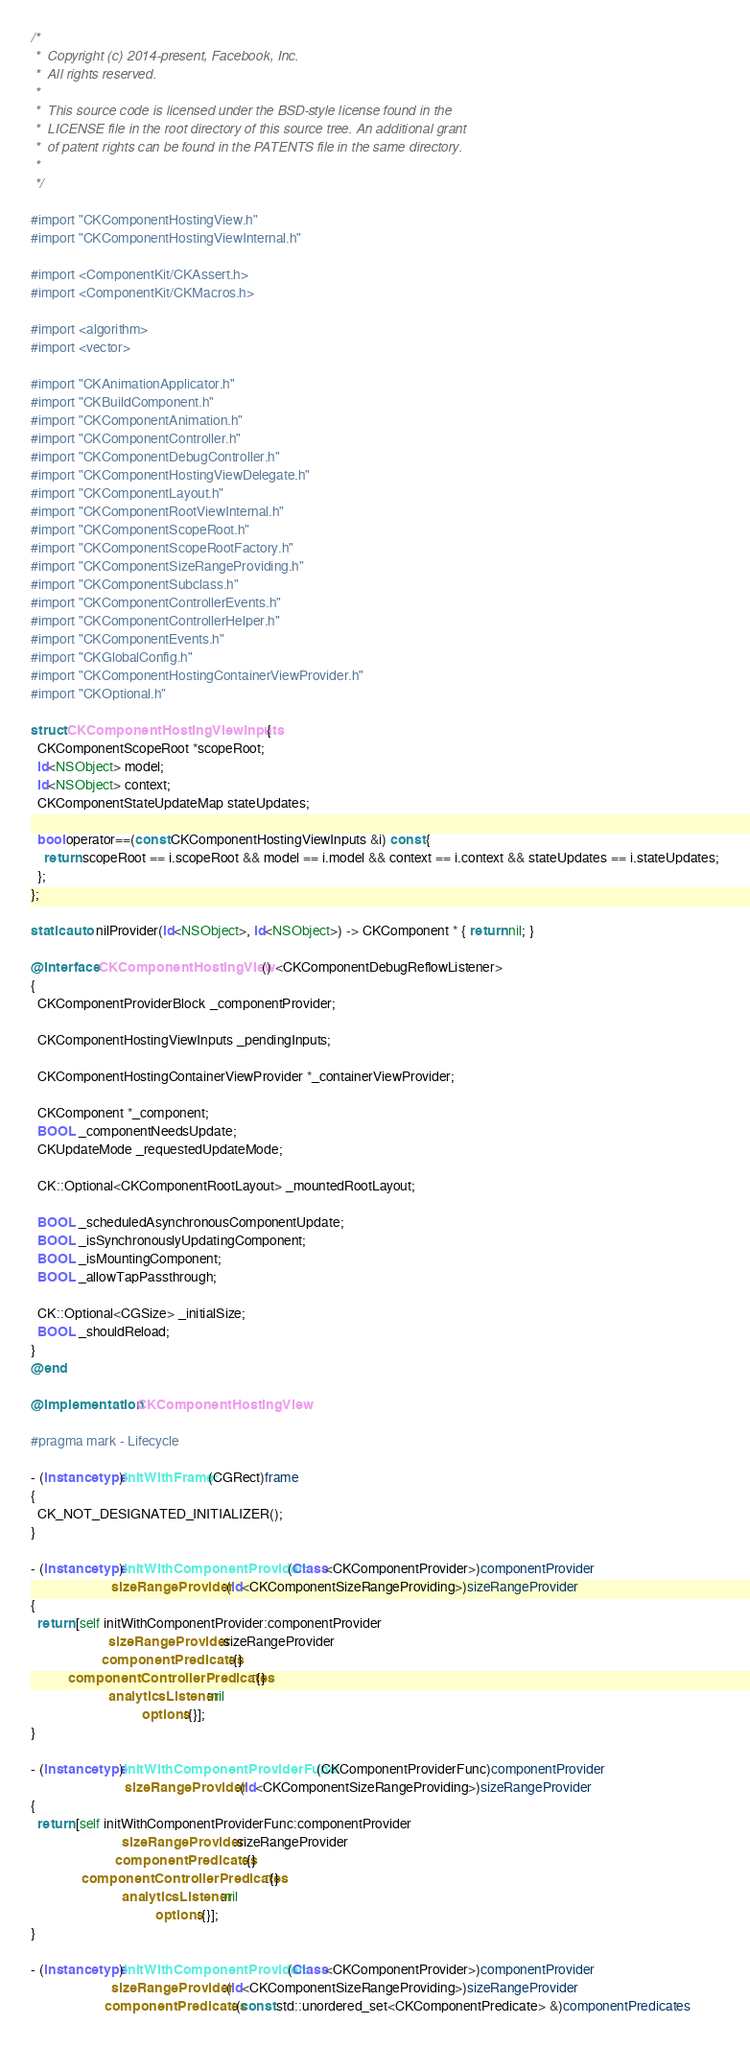<code> <loc_0><loc_0><loc_500><loc_500><_ObjectiveC_>/*
 *  Copyright (c) 2014-present, Facebook, Inc.
 *  All rights reserved.
 *
 *  This source code is licensed under the BSD-style license found in the
 *  LICENSE file in the root directory of this source tree. An additional grant
 *  of patent rights can be found in the PATENTS file in the same directory.
 *
 */

#import "CKComponentHostingView.h"
#import "CKComponentHostingViewInternal.h"

#import <ComponentKit/CKAssert.h>
#import <ComponentKit/CKMacros.h>

#import <algorithm>
#import <vector>

#import "CKAnimationApplicator.h"
#import "CKBuildComponent.h"
#import "CKComponentAnimation.h"
#import "CKComponentController.h"
#import "CKComponentDebugController.h"
#import "CKComponentHostingViewDelegate.h"
#import "CKComponentLayout.h"
#import "CKComponentRootViewInternal.h"
#import "CKComponentScopeRoot.h"
#import "CKComponentScopeRootFactory.h"
#import "CKComponentSizeRangeProviding.h"
#import "CKComponentSubclass.h"
#import "CKComponentControllerEvents.h"
#import "CKComponentControllerHelper.h"
#import "CKComponentEvents.h"
#import "CKGlobalConfig.h"
#import "CKComponentHostingContainerViewProvider.h"
#import "CKOptional.h"

struct CKComponentHostingViewInputs {
  CKComponentScopeRoot *scopeRoot;
  id<NSObject> model;
  id<NSObject> context;
  CKComponentStateUpdateMap stateUpdates;

  bool operator==(const CKComponentHostingViewInputs &i) const {
    return scopeRoot == i.scopeRoot && model == i.model && context == i.context && stateUpdates == i.stateUpdates;
  };
};

static auto nilProvider(id<NSObject>, id<NSObject>) -> CKComponent * { return nil; }

@interface CKComponentHostingView () <CKComponentDebugReflowListener>
{
  CKComponentProviderBlock _componentProvider;

  CKComponentHostingViewInputs _pendingInputs;

  CKComponentHostingContainerViewProvider *_containerViewProvider;

  CKComponent *_component;
  BOOL _componentNeedsUpdate;
  CKUpdateMode _requestedUpdateMode;

  CK::Optional<CKComponentRootLayout> _mountedRootLayout;

  BOOL _scheduledAsynchronousComponentUpdate;
  BOOL _isSynchronouslyUpdatingComponent;
  BOOL _isMountingComponent;
  BOOL _allowTapPassthrough;

  CK::Optional<CGSize> _initialSize;
  BOOL _shouldReload;
}
@end

@implementation CKComponentHostingView

#pragma mark - Lifecycle

- (instancetype)initWithFrame:(CGRect)frame
{
  CK_NOT_DESIGNATED_INITIALIZER();
}

- (instancetype)initWithComponentProvider:(Class<CKComponentProvider>)componentProvider
                        sizeRangeProvider:(id<CKComponentSizeRangeProviding>)sizeRangeProvider
{
  return [self initWithComponentProvider:componentProvider
                       sizeRangeProvider:sizeRangeProvider
                     componentPredicates:{}
           componentControllerPredicates:{}
                       analyticsListener:nil
                                 options:{}];
}

- (instancetype)initWithComponentProviderFunc:(CKComponentProviderFunc)componentProvider
                            sizeRangeProvider:(id<CKComponentSizeRangeProviding>)sizeRangeProvider
{
  return [self initWithComponentProviderFunc:componentProvider
                           sizeRangeProvider:sizeRangeProvider
                         componentPredicates:{}
               componentControllerPredicates:{}
                           analyticsListener:nil
                                     options:{}];
}

- (instancetype)initWithComponentProvider:(Class<CKComponentProvider>)componentProvider
                        sizeRangeProvider:(id<CKComponentSizeRangeProviding>)sizeRangeProvider
                      componentPredicates:(const std::unordered_set<CKComponentPredicate> &)componentPredicates</code> 